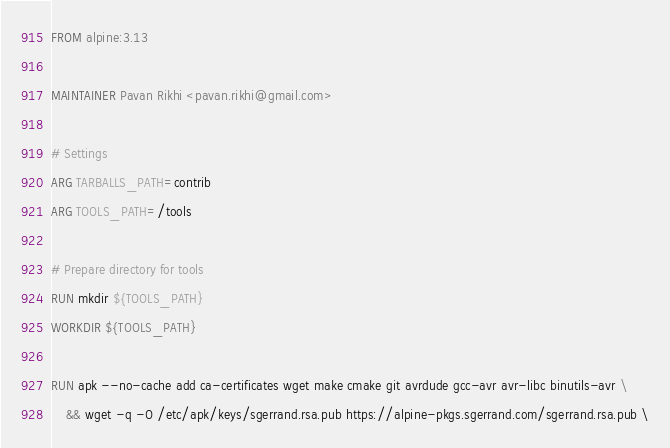<code> <loc_0><loc_0><loc_500><loc_500><_Dockerfile_>FROM alpine:3.13

MAINTAINER Pavan Rikhi <pavan.rikhi@gmail.com>

# Settings
ARG TARBALLS_PATH=contrib
ARG TOOLS_PATH=/tools

# Prepare directory for tools
RUN mkdir ${TOOLS_PATH}
WORKDIR ${TOOLS_PATH}

RUN apk --no-cache add ca-certificates wget make cmake git avrdude gcc-avr avr-libc binutils-avr \
	&& wget -q -O /etc/apk/keys/sgerrand.rsa.pub https://alpine-pkgs.sgerrand.com/sgerrand.rsa.pub \</code> 